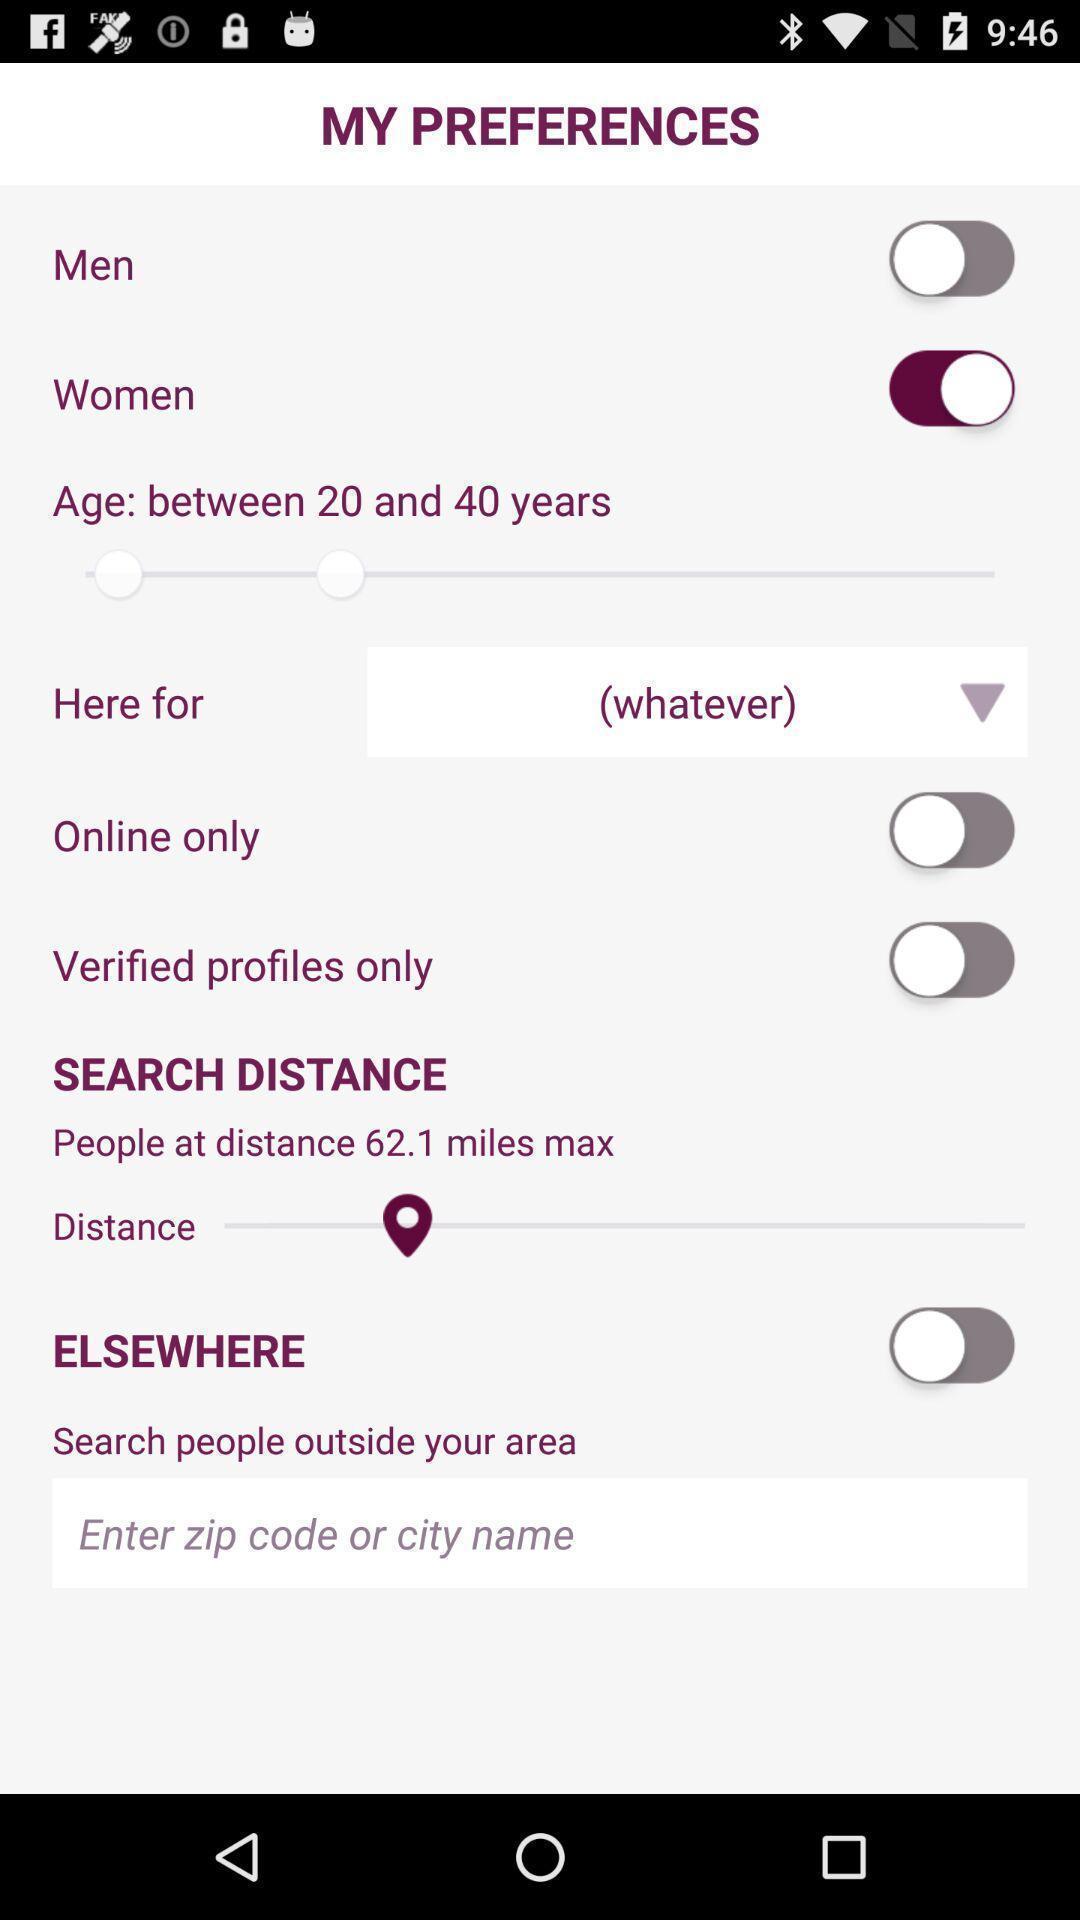Summarize the information in this screenshot. Screen showing my preferences. 